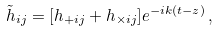<formula> <loc_0><loc_0><loc_500><loc_500>\tilde { h } _ { i j } = [ h _ { + i j } + h _ { \times i j } ] e ^ { - i k ( t - z ) } \, ,</formula> 